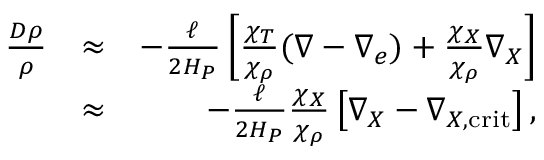<formula> <loc_0><loc_0><loc_500><loc_500>\begin{array} { r l r } { { \frac { D \rho } { \rho } } } & { \approx } & { - { \frac { \ell } { 2 H _ { P } } } \left [ { \frac { \chi _ { T } } { \chi _ { \rho } } } ( \nabla - \nabla _ { e } ) + { \frac { \chi _ { X } } { \chi _ { \rho } } } \nabla _ { X } \right ] } \\ & { \approx } & { - { \frac { \ell } { 2 H _ { P } } } { \frac { \chi _ { X } } { \chi _ { \rho } } } \left [ \nabla _ { X } - \nabla _ { X , c r i t } \right ] , } \end{array}</formula> 